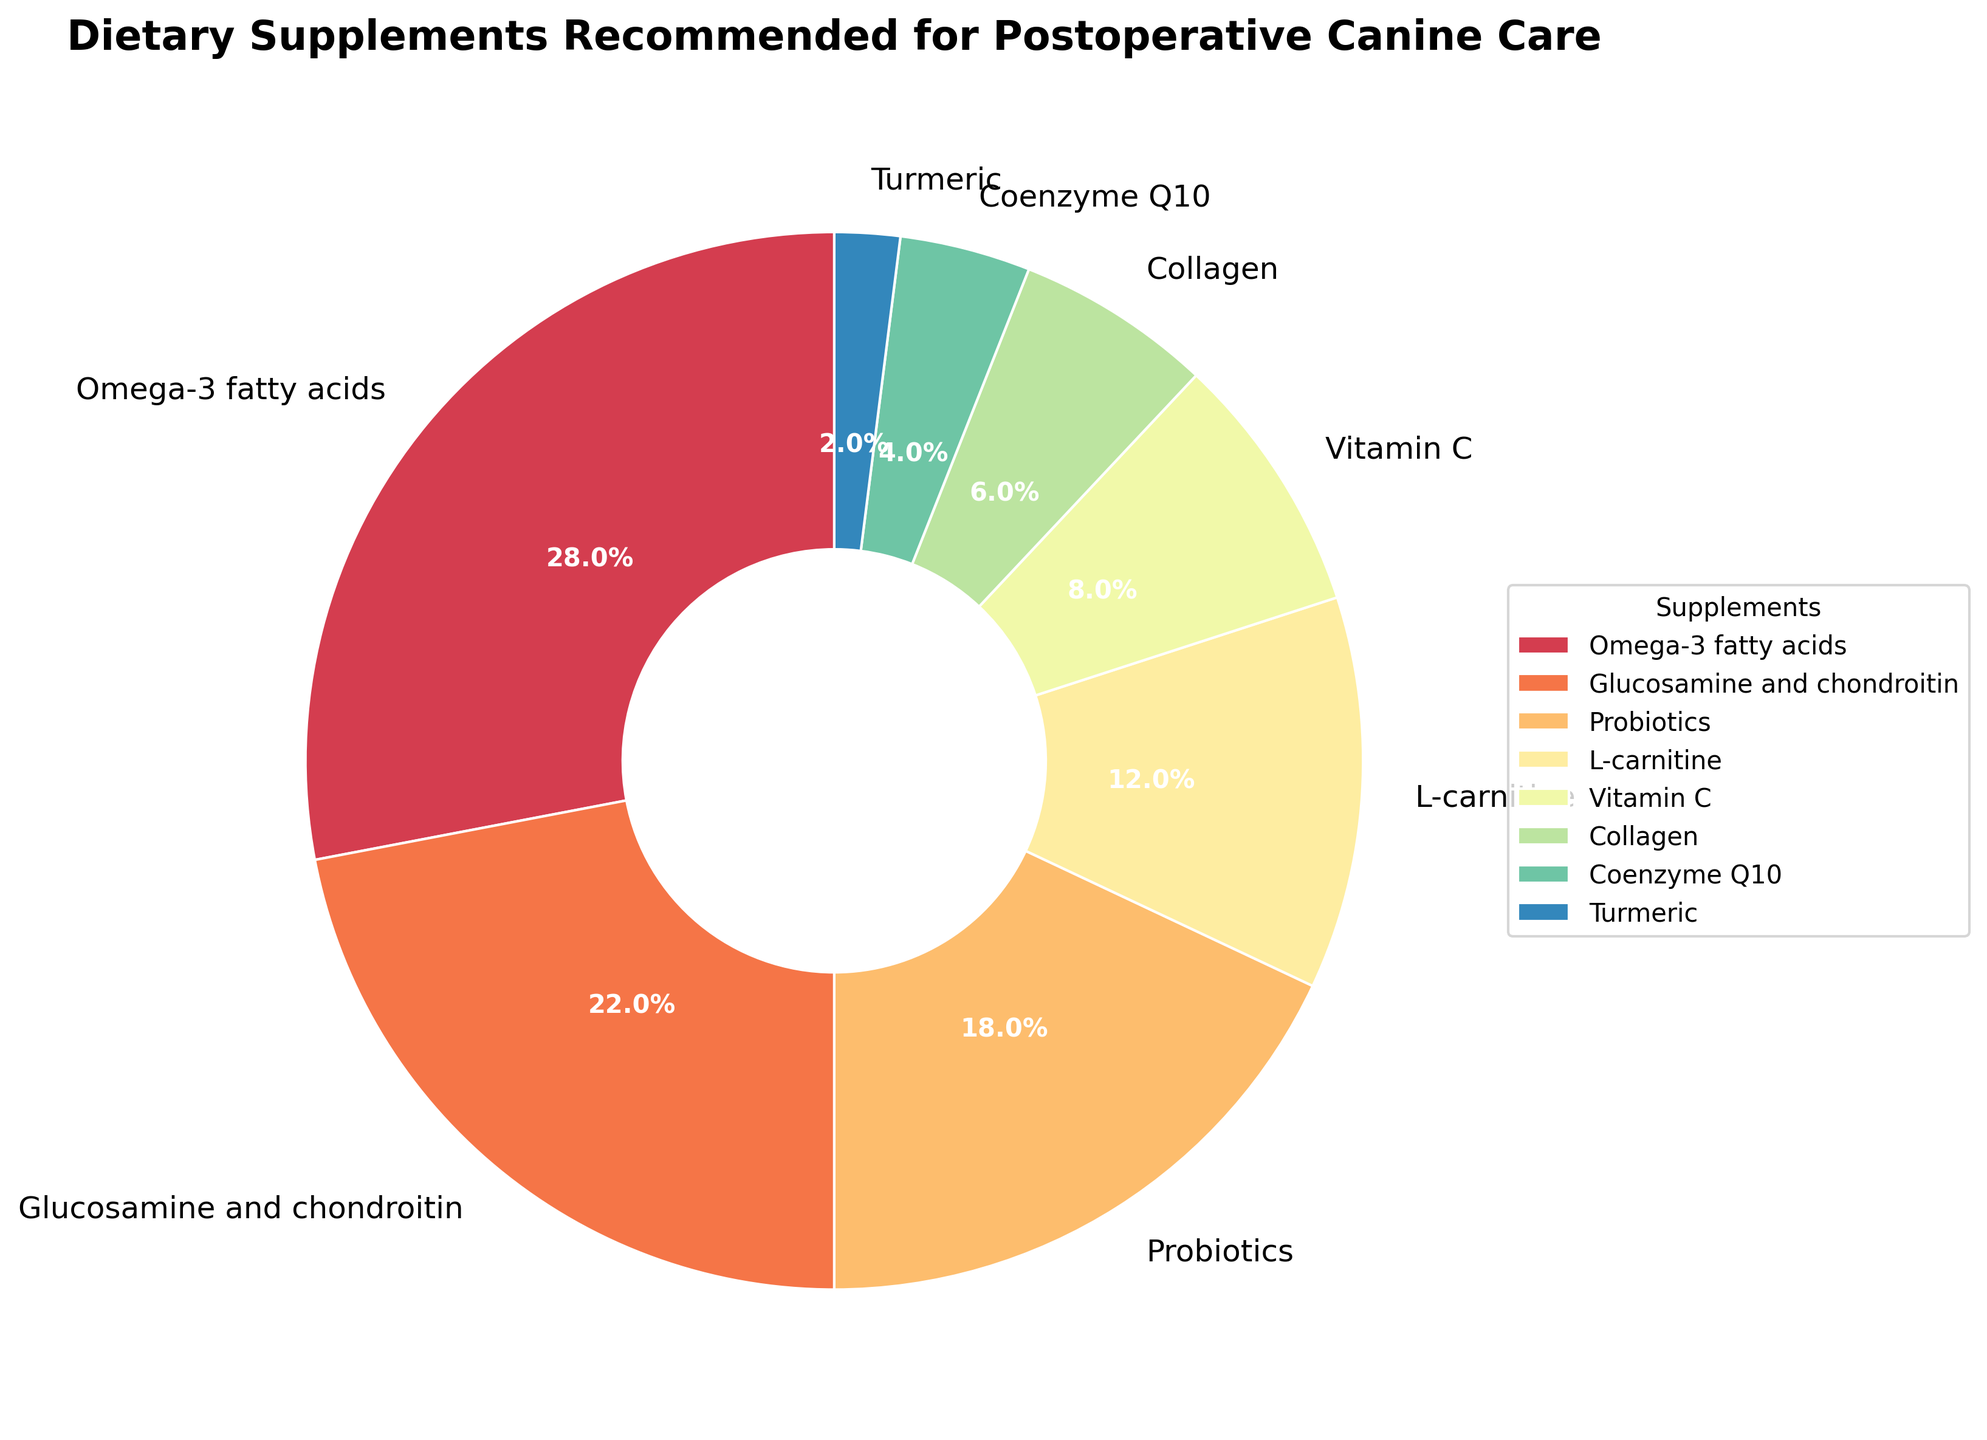Which supplement is recommended by the highest percentage of veterinarians? The pie chart clearly shows the largest wedge corresponds to Omega-3 fatty acids, which indicates it is recommended by the highest percentage of veterinarians.
Answer: Omega-3 fatty acids Which two supplements are recommended by exactly 10% or less of veterinarians? The chart indicates that Vitamin C (8%), Collagen (6%), Coenzyme Q10 (4%), and Turmeric (2%) are all below 10%. Summing their percentages: 8% + 6% + 4% + 2% = 20% of veterinarians recommend these supplements. From these, specify the two: Vitamin C and Collagen are under 10%.
Answer: Vitamin C and Collagen What is the combined percentage of veterinarians recommending Glucosamine and Chondroitin and Probiotics? Glucosamine and Chondroitin is recommended by 22% and Probiotics by 18%, hence combined they total 22% + 18% = 40%.
Answer: 40% Out of the supplements recommended by less than 10% of veterinarians, which one has the lowest percentage? From the pie chart, the smallest wedge belongs to Turmeric, which is recommended by 2% of veterinarians, the lowest among those recommended by less than 10%.
Answer: Turmeric Which supplement is recommended by more veterinarians: L-carnitine or Vitamin C? The pie chart shows L-carnitine recommended by 12% and Vitamin C by 8%, so L-carnitine is recommended by more veterinarians.
Answer: L-carnitine 